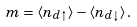<formula> <loc_0><loc_0><loc_500><loc_500>m = \langle n _ { d \uparrow } \rangle - \langle n _ { d \downarrow } \rangle \, .</formula> 